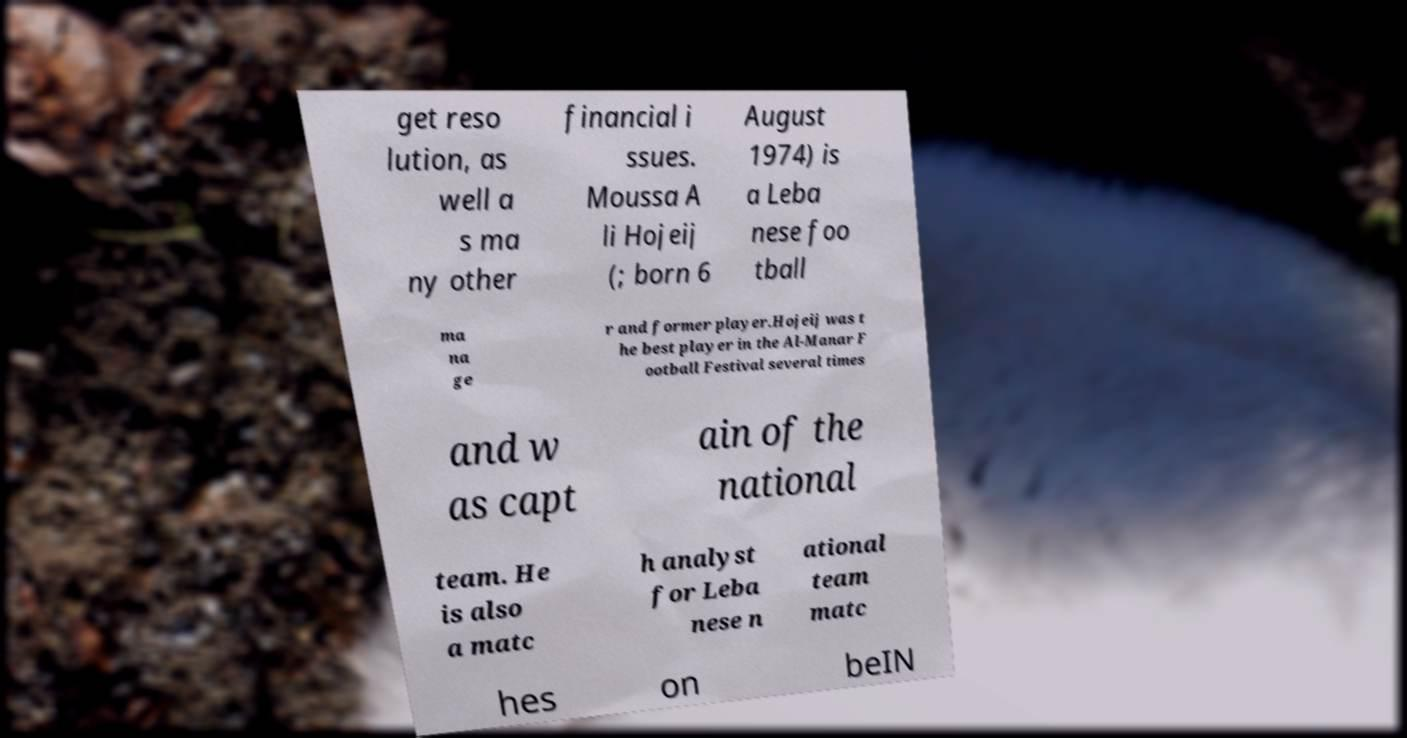There's text embedded in this image that I need extracted. Can you transcribe it verbatim? get reso lution, as well a s ma ny other financial i ssues. Moussa A li Hojeij (; born 6 August 1974) is a Leba nese foo tball ma na ge r and former player.Hojeij was t he best player in the Al-Manar F ootball Festival several times and w as capt ain of the national team. He is also a matc h analyst for Leba nese n ational team matc hes on beIN 